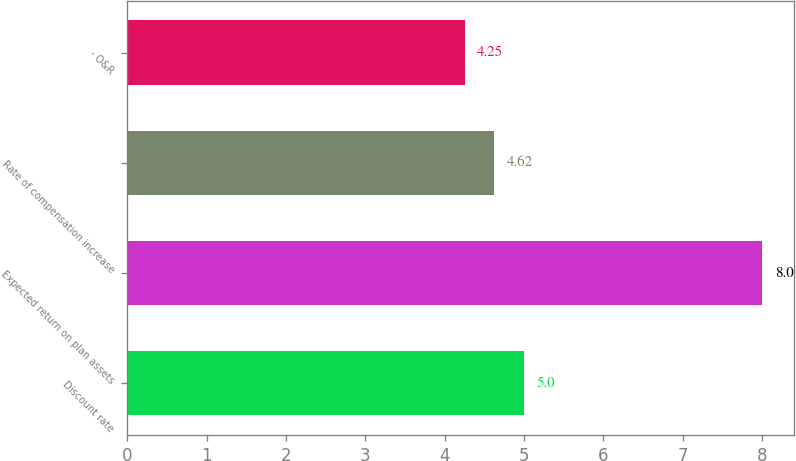Convert chart to OTSL. <chart><loc_0><loc_0><loc_500><loc_500><bar_chart><fcel>Discount rate<fcel>Expected return on plan assets<fcel>Rate of compensation increase<fcel>- O&R<nl><fcel>5<fcel>8<fcel>4.62<fcel>4.25<nl></chart> 